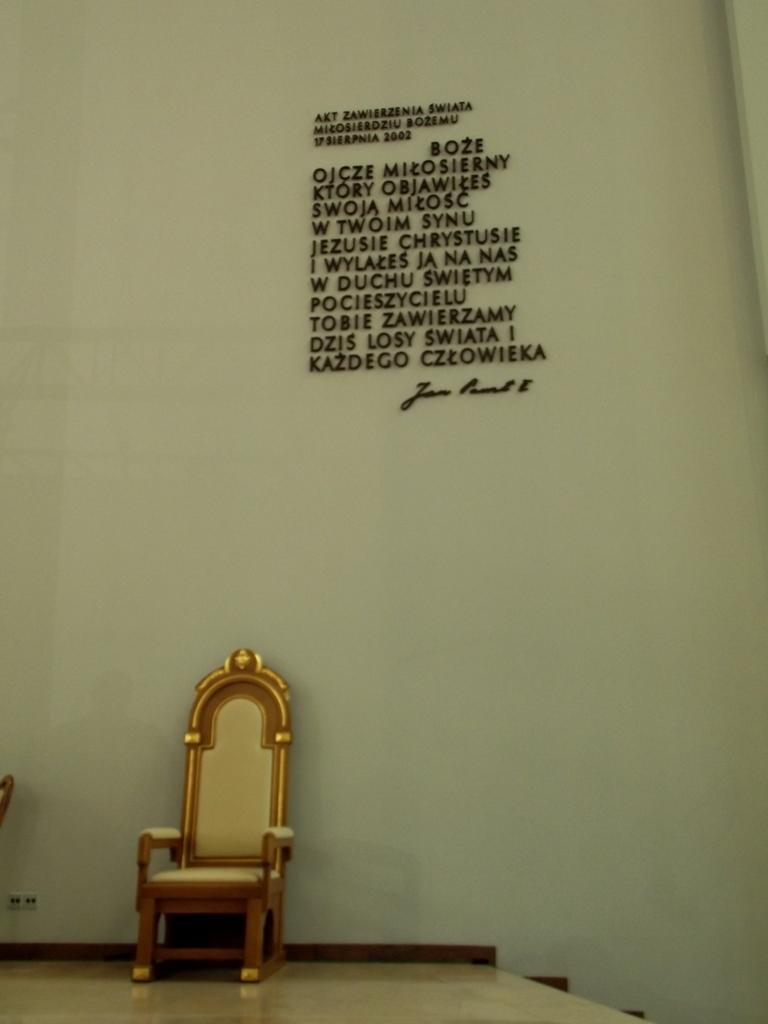What color is the chair in the image? The chair in the image is brown. Where is the chair located in the image? The chair is on the floor. What can be seen in the background of the image? There is a white wall in the background of the image. What is written on the white wall? Something is written on the white wall. Can you tell me how many robins are sitting on the chair in the image? There are no robins present in the image; it only features a brown chair on the floor and a white wall with writing in the background. 